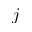Convert formula to latex. <formula><loc_0><loc_0><loc_500><loc_500>j</formula> 